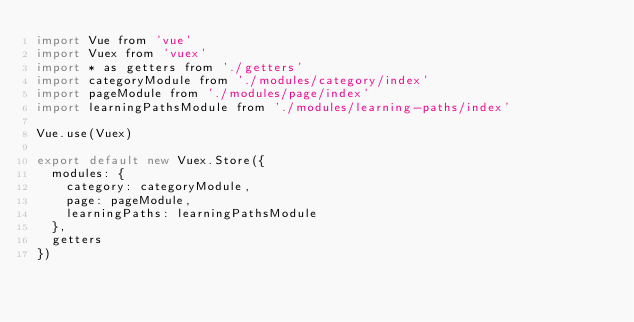<code> <loc_0><loc_0><loc_500><loc_500><_JavaScript_>import Vue from 'vue'
import Vuex from 'vuex'
import * as getters from './getters'
import categoryModule from './modules/category/index'
import pageModule from './modules/page/index'
import learningPathsModule from './modules/learning-paths/index'

Vue.use(Vuex)

export default new Vuex.Store({
  modules: {
    category: categoryModule,
    page: pageModule,
    learningPaths: learningPathsModule
  },
  getters
})
</code> 